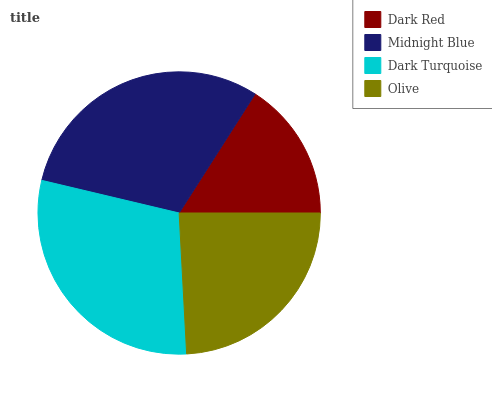Is Dark Red the minimum?
Answer yes or no. Yes. Is Midnight Blue the maximum?
Answer yes or no. Yes. Is Dark Turquoise the minimum?
Answer yes or no. No. Is Dark Turquoise the maximum?
Answer yes or no. No. Is Midnight Blue greater than Dark Turquoise?
Answer yes or no. Yes. Is Dark Turquoise less than Midnight Blue?
Answer yes or no. Yes. Is Dark Turquoise greater than Midnight Blue?
Answer yes or no. No. Is Midnight Blue less than Dark Turquoise?
Answer yes or no. No. Is Dark Turquoise the high median?
Answer yes or no. Yes. Is Olive the low median?
Answer yes or no. Yes. Is Midnight Blue the high median?
Answer yes or no. No. Is Dark Red the low median?
Answer yes or no. No. 